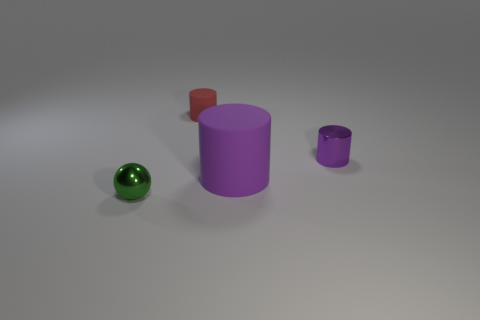Subtract all green cylinders. Subtract all yellow cubes. How many cylinders are left? 3 Add 4 red matte things. How many objects exist? 8 Subtract all cylinders. How many objects are left? 1 Add 4 small spheres. How many small spheres are left? 5 Add 3 shiny balls. How many shiny balls exist? 4 Subtract 0 gray blocks. How many objects are left? 4 Subtract all tiny red rubber cylinders. Subtract all yellow matte cubes. How many objects are left? 3 